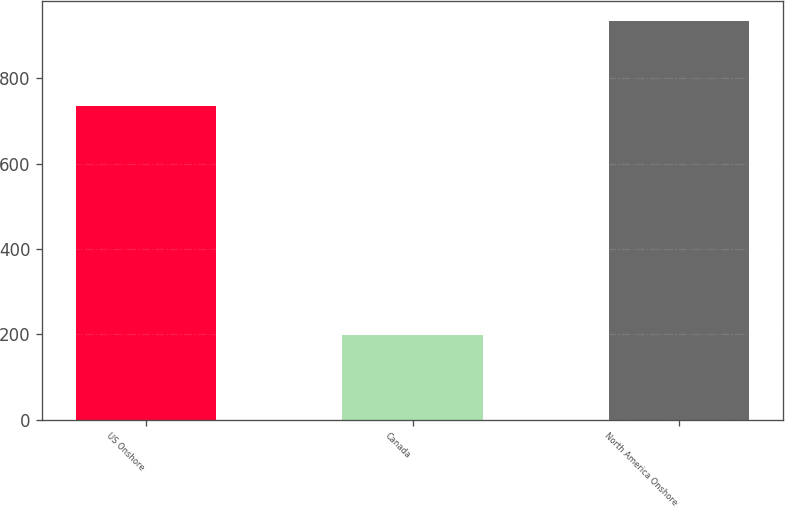<chart> <loc_0><loc_0><loc_500><loc_500><bar_chart><fcel>US Onshore<fcel>Canada<fcel>North America Onshore<nl><fcel>736<fcel>199<fcel>935<nl></chart> 